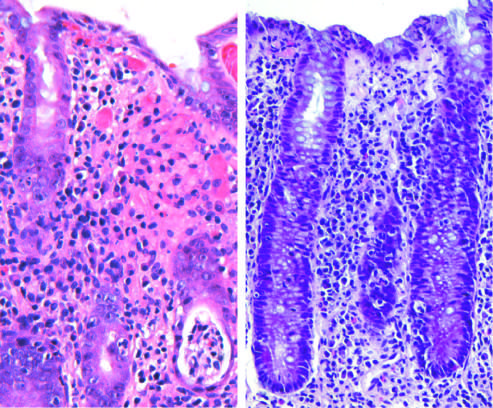s enteroinvasive escherichia coli infection similar to other acute, self-limited colitides?
Answer the question using a single word or phrase. Yes 